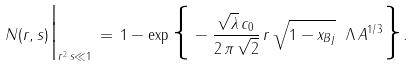<formula> <loc_0><loc_0><loc_500><loc_500>N ( r , s ) \Big | _ { r ^ { 2 } \, s \ll 1 } \, = \, 1 - \exp \Big \{ - \frac { \sqrt { \lambda } \, c _ { 0 } } { 2 \, \pi \, \sqrt { 2 } } \, r \, \sqrt { 1 - x _ { B j } } \ \Lambda \, A ^ { 1 / 3 } \Big \} .</formula> 